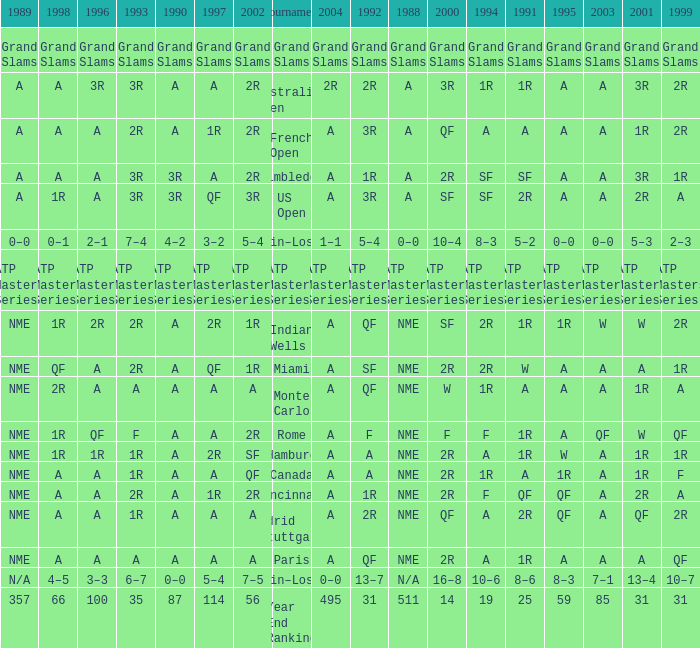Could you help me parse every detail presented in this table? {'header': ['1989', '1998', '1996', '1993', '1990', '1997', '2002', 'Tournament', '2004', '1992', '1988', '2000', '1994', '1991', '1995', '2003', '2001', '1999'], 'rows': [['Grand Slams', 'Grand Slams', 'Grand Slams', 'Grand Slams', 'Grand Slams', 'Grand Slams', 'Grand Slams', 'Grand Slams', 'Grand Slams', 'Grand Slams', 'Grand Slams', 'Grand Slams', 'Grand Slams', 'Grand Slams', 'Grand Slams', 'Grand Slams', 'Grand Slams', 'Grand Slams'], ['A', 'A', '3R', '3R', 'A', 'A', '2R', 'Australian Open', '2R', '2R', 'A', '3R', '1R', '1R', 'A', 'A', '3R', '2R'], ['A', 'A', 'A', '2R', 'A', '1R', '2R', 'French Open', 'A', '3R', 'A', 'QF', 'A', 'A', 'A', 'A', '1R', '2R'], ['A', 'A', 'A', '3R', '3R', 'A', '2R', 'Wimbledon', 'A', '1R', 'A', '2R', 'SF', 'SF', 'A', 'A', '3R', '1R'], ['A', '1R', 'A', '3R', '3R', 'QF', '3R', 'US Open', 'A', '3R', 'A', 'SF', 'SF', '2R', 'A', 'A', '2R', 'A'], ['0–0', '0–1', '2–1', '7–4', '4–2', '3–2', '5–4', 'Win–Loss', '1–1', '5–4', '0–0', '10–4', '8–3', '5–2', '0–0', '0–0', '5–3', '2–3'], ['ATP Masters Series', 'ATP Masters Series', 'ATP Masters Series', 'ATP Masters Series', 'ATP Masters Series', 'ATP Masters Series', 'ATP Masters Series', 'ATP Masters Series', 'ATP Masters Series', 'ATP Masters Series', 'ATP Masters Series', 'ATP Masters Series', 'ATP Masters Series', 'ATP Masters Series', 'ATP Masters Series', 'ATP Masters Series', 'ATP Masters Series', 'ATP Masters Series'], ['NME', '1R', '2R', '2R', 'A', '2R', '1R', 'Indian Wells', 'A', 'QF', 'NME', 'SF', '2R', '1R', '1R', 'W', 'W', '2R'], ['NME', 'QF', 'A', '2R', 'A', 'QF', '1R', 'Miami', 'A', 'SF', 'NME', '2R', '2R', 'W', 'A', 'A', 'A', '1R'], ['NME', '2R', 'A', 'A', 'A', 'A', 'A', 'Monte Carlo', 'A', 'QF', 'NME', 'W', '1R', 'A', 'A', 'A', '1R', 'A'], ['NME', '1R', 'QF', 'F', 'A', 'A', '2R', 'Rome', 'A', 'F', 'NME', 'F', 'F', '1R', 'A', 'QF', 'W', 'QF'], ['NME', '1R', '1R', '1R', 'A', '2R', 'SF', 'Hamburg', 'A', 'A', 'NME', '2R', 'A', '1R', 'W', 'A', '1R', '1R'], ['NME', 'A', 'A', '1R', 'A', 'A', 'QF', 'Canada', 'A', 'A', 'NME', '2R', '1R', 'A', '1R', 'A', '1R', 'F'], ['NME', 'A', 'A', '2R', 'A', '1R', '2R', 'Cincinnati', 'A', '1R', 'NME', '2R', 'F', 'QF', 'QF', 'A', '2R', 'A'], ['NME', 'A', 'A', '1R', 'A', 'A', 'A', 'Madrid (Stuttgart)', 'A', '2R', 'NME', 'QF', 'A', '2R', 'QF', 'A', 'QF', '2R'], ['NME', 'A', 'A', 'A', 'A', 'A', 'A', 'Paris', 'A', 'QF', 'NME', '2R', 'A', '1R', 'A', 'A', 'A', 'QF'], ['N/A', '4–5', '3–3', '6–7', '0–0', '5–4', '7–5', 'Win–Loss', '0–0', '13–7', 'N/A', '16–8', '10–6', '8–6', '8–3', '7–1', '13–4', '10–7'], ['357', '66', '100', '35', '87', '114', '56', 'Year End Ranking', '495', '31', '511', '14', '19', '25', '59', '85', '31', '31']]} What shows for 1988 when 1994 shows 10–6? N/A. 